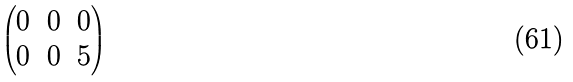Convert formula to latex. <formula><loc_0><loc_0><loc_500><loc_500>\begin{pmatrix} 0 & 0 & 0 \\ 0 & 0 & 5 \end{pmatrix}</formula> 